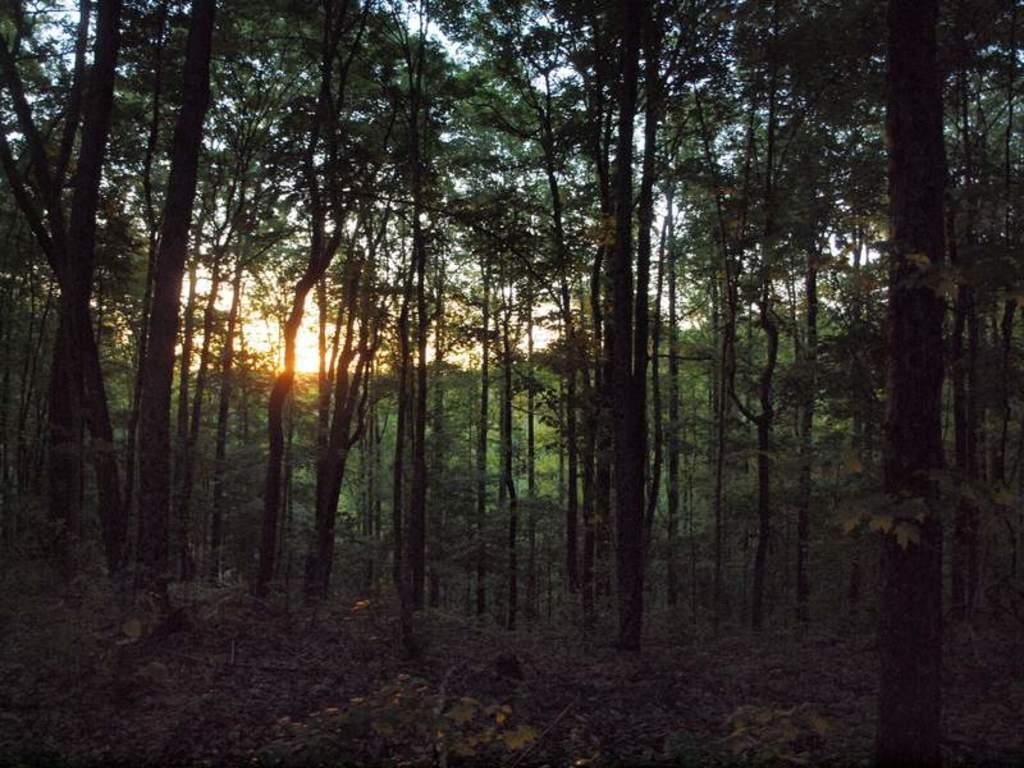What is located in the foreground of the image? There are plants in the foreground of the image. What can be seen behind the plants in the image? There are many trees visible behind the plants in the image. What type of hat can be seen hanging from the trees in the image? There is no hat present in the image; it only features plants in the foreground and trees in the background. 